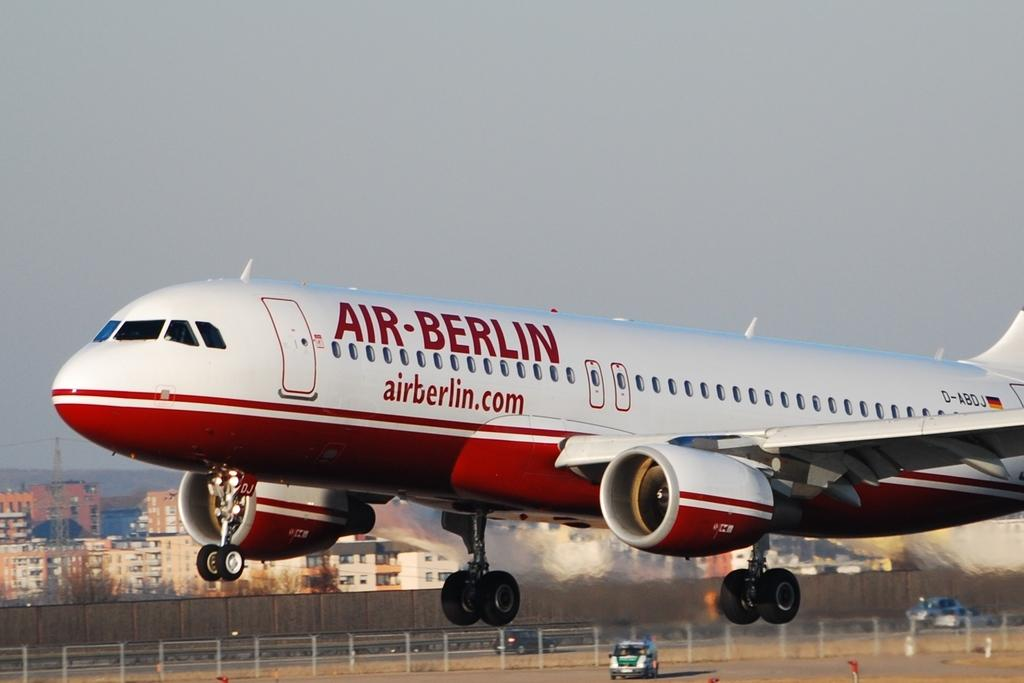<image>
Relay a brief, clear account of the picture shown. a red and white airplane with the air berlin logo on its side. 